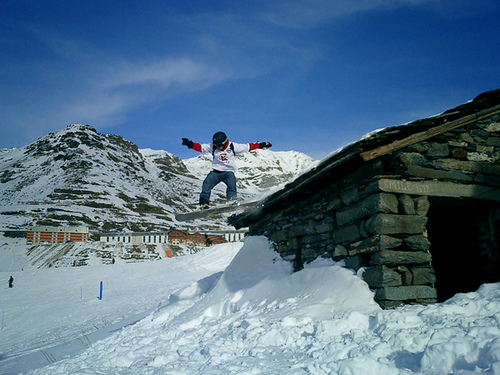<image>What is the purpose of the building to the left? It is ambiguous what the purpose of the building to the left is. It could be a shelter, a house, a hotel, a factory, a ski lodge, or house for snowboarders. What is the purpose of the building to the left? The purpose of the building to the left is unknown. It can be a hotel, a shelter, a ski lodge or a factory. 